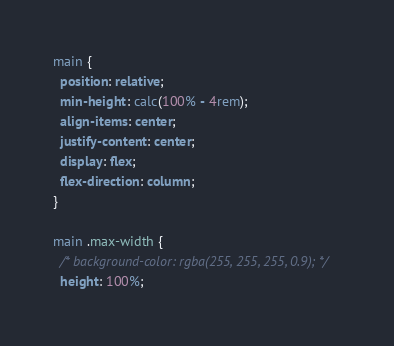<code> <loc_0><loc_0><loc_500><loc_500><_CSS_>main {
  position: relative;
  min-height: calc(100% - 4rem);
  align-items: center;
  justify-content: center;
  display: flex;
  flex-direction: column;
}

main .max-width {
  /* background-color: rgba(255, 255, 255, 0.9); */
  height: 100%;</code> 